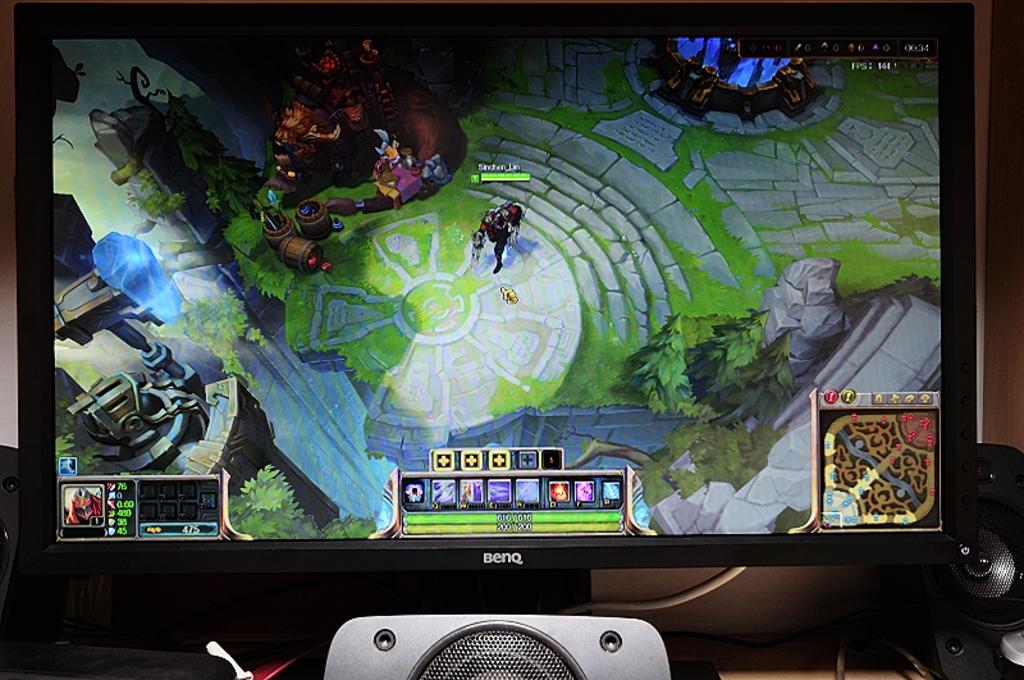What is the brand of the computer screen?
Ensure brevity in your answer.  Benq. Is that monitor made by benq?
Your response must be concise. Yes. 